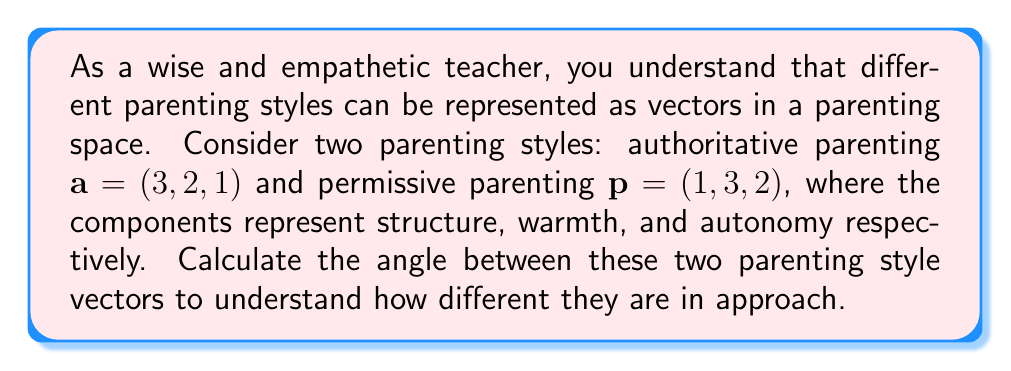Could you help me with this problem? To find the angle between two vectors, we can use the dot product formula:

$$\cos \theta = \frac{\mathbf{a} \cdot \mathbf{p}}{|\mathbf{a}||\mathbf{p}|}$$

Where $\theta$ is the angle between the vectors, $\mathbf{a} \cdot \mathbf{p}$ is the dot product, and $|\mathbf{a}|$ and $|\mathbf{p}|$ are the magnitudes of the vectors.

Step 1: Calculate the dot product
$$\mathbf{a} \cdot \mathbf{p} = (3)(1) + (2)(3) + (1)(2) = 3 + 6 + 2 = 11$$

Step 2: Calculate the magnitudes
$$|\mathbf{a}| = \sqrt{3^2 + 2^2 + 1^2} = \sqrt{14}$$
$$|\mathbf{p}| = \sqrt{1^2 + 3^2 + 2^2} = \sqrt{14}$$

Step 3: Apply the formula
$$\cos \theta = \frac{11}{\sqrt{14} \sqrt{14}} = \frac{11}{14}$$

Step 4: Take the inverse cosine (arccos) of both sides
$$\theta = \arccos(\frac{11}{14})$$

Step 5: Convert to degrees
$$\theta = \arccos(\frac{11}{14}) \cdot \frac{180^{\circ}}{\pi}$$
Answer: $\theta \approx 38.21^{\circ}$ 